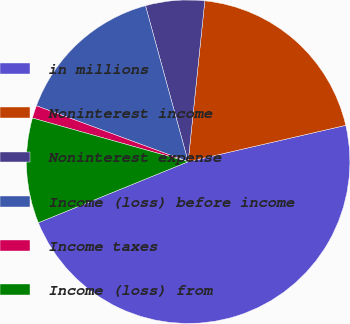Convert chart. <chart><loc_0><loc_0><loc_500><loc_500><pie_chart><fcel>in millions<fcel>Noninterest income<fcel>Noninterest expense<fcel>Income (loss) before income<fcel>Income taxes<fcel>Income (loss) from<nl><fcel>47.45%<fcel>19.75%<fcel>5.89%<fcel>15.13%<fcel>1.27%<fcel>10.51%<nl></chart> 